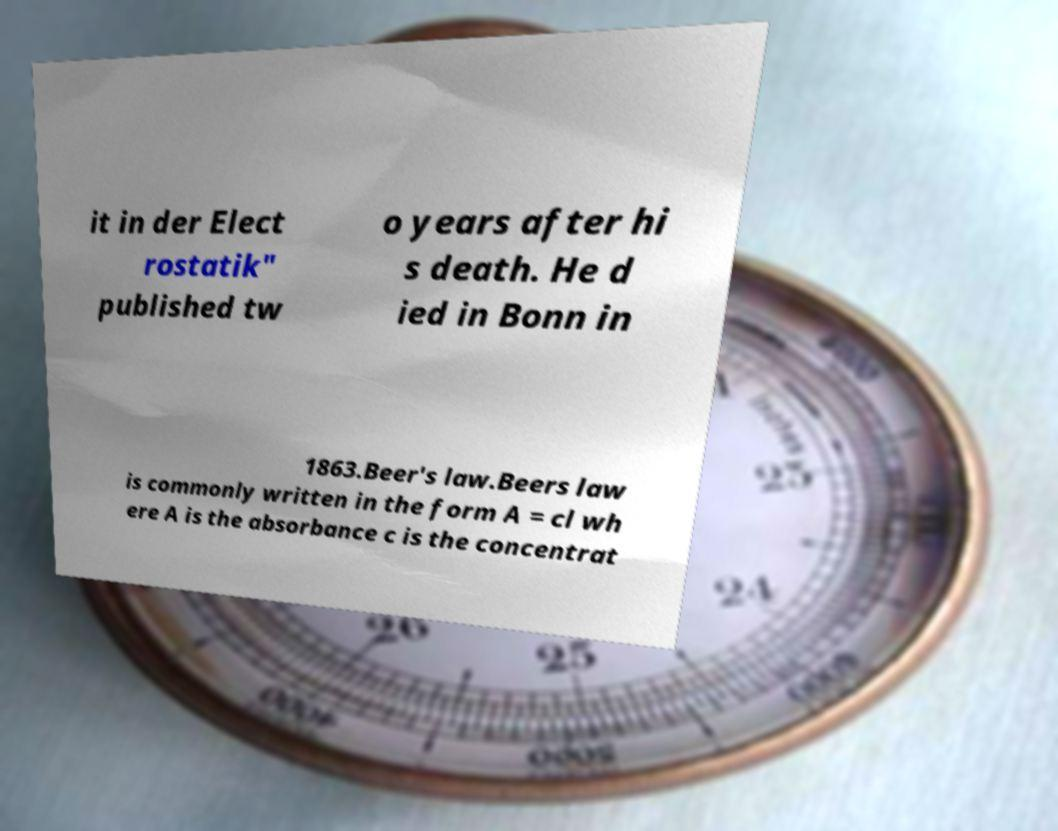Could you assist in decoding the text presented in this image and type it out clearly? it in der Elect rostatik" published tw o years after hi s death. He d ied in Bonn in 1863.Beer's law.Beers law is commonly written in the form A = cl wh ere A is the absorbance c is the concentrat 